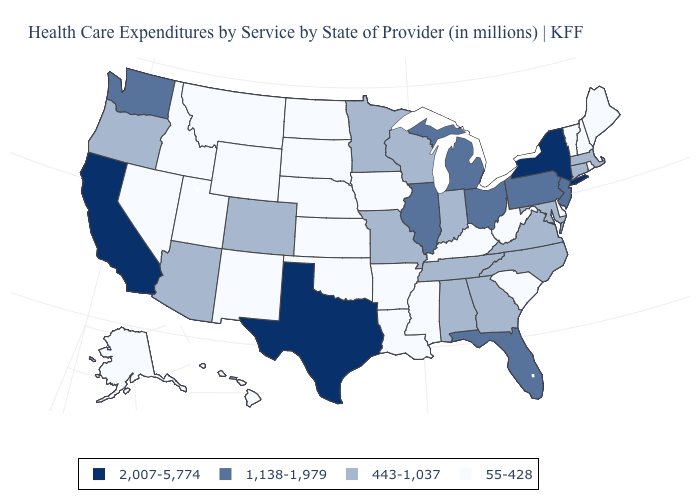What is the value of Colorado?
Concise answer only. 443-1,037. What is the value of Pennsylvania?
Be succinct. 1,138-1,979. How many symbols are there in the legend?
Be succinct. 4. Does Texas have the highest value in the USA?
Answer briefly. Yes. Does Virginia have the lowest value in the South?
Write a very short answer. No. What is the value of Nebraska?
Quick response, please. 55-428. Does Illinois have the same value as Oklahoma?
Keep it brief. No. Name the states that have a value in the range 55-428?
Keep it brief. Alaska, Arkansas, Delaware, Hawaii, Idaho, Iowa, Kansas, Kentucky, Louisiana, Maine, Mississippi, Montana, Nebraska, Nevada, New Hampshire, New Mexico, North Dakota, Oklahoma, Rhode Island, South Carolina, South Dakota, Utah, Vermont, West Virginia, Wyoming. What is the value of North Dakota?
Write a very short answer. 55-428. Is the legend a continuous bar?
Give a very brief answer. No. What is the lowest value in the USA?
Give a very brief answer. 55-428. What is the highest value in the Northeast ?
Answer briefly. 2,007-5,774. Does Virginia have the lowest value in the USA?
Quick response, please. No. Which states have the highest value in the USA?
Answer briefly. California, New York, Texas. What is the value of California?
Quick response, please. 2,007-5,774. 